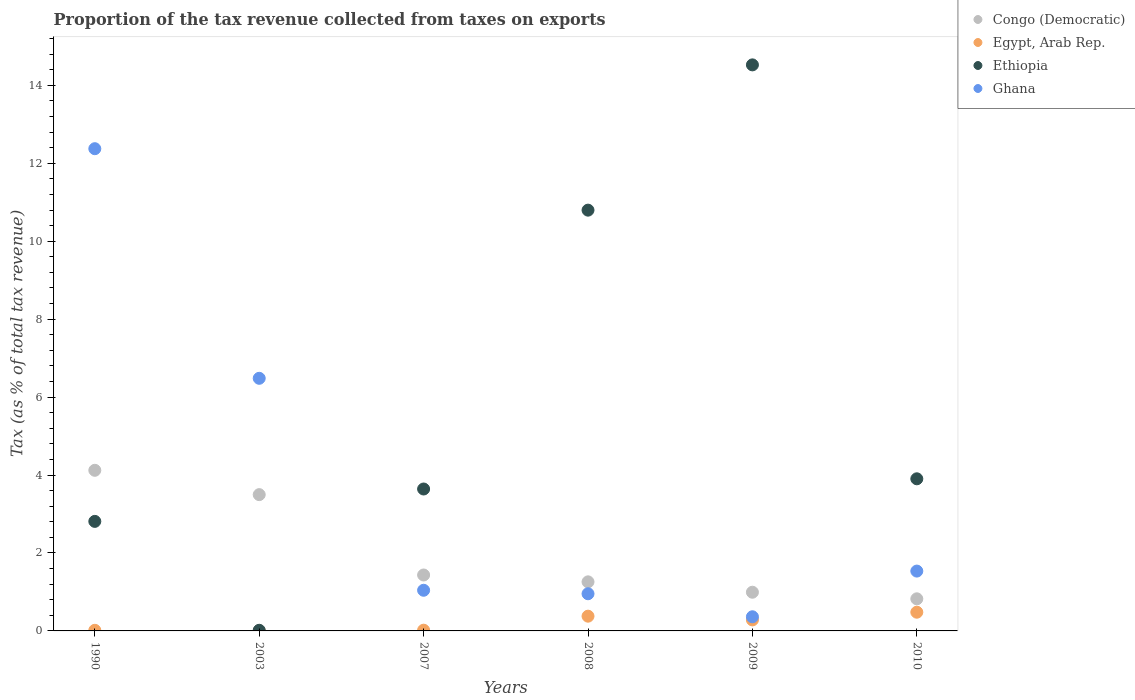How many different coloured dotlines are there?
Provide a succinct answer. 4. What is the proportion of the tax revenue collected in Egypt, Arab Rep. in 2009?
Provide a succinct answer. 0.28. Across all years, what is the maximum proportion of the tax revenue collected in Egypt, Arab Rep.?
Provide a succinct answer. 0.48. Across all years, what is the minimum proportion of the tax revenue collected in Ghana?
Your response must be concise. 0.36. In which year was the proportion of the tax revenue collected in Ethiopia minimum?
Make the answer very short. 2003. What is the total proportion of the tax revenue collected in Ghana in the graph?
Ensure brevity in your answer.  22.75. What is the difference between the proportion of the tax revenue collected in Egypt, Arab Rep. in 2003 and that in 2008?
Offer a very short reply. -0.38. What is the difference between the proportion of the tax revenue collected in Ghana in 2009 and the proportion of the tax revenue collected in Egypt, Arab Rep. in 2010?
Your answer should be compact. -0.12. What is the average proportion of the tax revenue collected in Congo (Democratic) per year?
Provide a succinct answer. 2.02. In the year 2008, what is the difference between the proportion of the tax revenue collected in Congo (Democratic) and proportion of the tax revenue collected in Ethiopia?
Give a very brief answer. -9.54. In how many years, is the proportion of the tax revenue collected in Ethiopia greater than 8.4 %?
Make the answer very short. 2. What is the ratio of the proportion of the tax revenue collected in Congo (Democratic) in 1990 to that in 2010?
Give a very brief answer. 5. Is the proportion of the tax revenue collected in Egypt, Arab Rep. in 2009 less than that in 2010?
Your response must be concise. Yes. Is the difference between the proportion of the tax revenue collected in Congo (Democratic) in 2003 and 2007 greater than the difference between the proportion of the tax revenue collected in Ethiopia in 2003 and 2007?
Keep it short and to the point. Yes. What is the difference between the highest and the second highest proportion of the tax revenue collected in Ethiopia?
Provide a succinct answer. 3.73. What is the difference between the highest and the lowest proportion of the tax revenue collected in Egypt, Arab Rep.?
Your answer should be very brief. 0.48. In how many years, is the proportion of the tax revenue collected in Ethiopia greater than the average proportion of the tax revenue collected in Ethiopia taken over all years?
Ensure brevity in your answer.  2. Is it the case that in every year, the sum of the proportion of the tax revenue collected in Egypt, Arab Rep. and proportion of the tax revenue collected in Ghana  is greater than the sum of proportion of the tax revenue collected in Ethiopia and proportion of the tax revenue collected in Congo (Democratic)?
Offer a terse response. No. Is the proportion of the tax revenue collected in Egypt, Arab Rep. strictly less than the proportion of the tax revenue collected in Ghana over the years?
Provide a short and direct response. Yes. How many dotlines are there?
Offer a terse response. 4. Are the values on the major ticks of Y-axis written in scientific E-notation?
Provide a short and direct response. No. How are the legend labels stacked?
Provide a succinct answer. Vertical. What is the title of the graph?
Ensure brevity in your answer.  Proportion of the tax revenue collected from taxes on exports. What is the label or title of the X-axis?
Give a very brief answer. Years. What is the label or title of the Y-axis?
Provide a succinct answer. Tax (as % of total tax revenue). What is the Tax (as % of total tax revenue) in Congo (Democratic) in 1990?
Make the answer very short. 4.12. What is the Tax (as % of total tax revenue) of Egypt, Arab Rep. in 1990?
Provide a short and direct response. 0.02. What is the Tax (as % of total tax revenue) of Ethiopia in 1990?
Keep it short and to the point. 2.81. What is the Tax (as % of total tax revenue) of Ghana in 1990?
Ensure brevity in your answer.  12.37. What is the Tax (as % of total tax revenue) of Congo (Democratic) in 2003?
Provide a short and direct response. 3.5. What is the Tax (as % of total tax revenue) in Egypt, Arab Rep. in 2003?
Your answer should be very brief. 0. What is the Tax (as % of total tax revenue) of Ethiopia in 2003?
Provide a short and direct response. 0.02. What is the Tax (as % of total tax revenue) of Ghana in 2003?
Offer a very short reply. 6.48. What is the Tax (as % of total tax revenue) of Congo (Democratic) in 2007?
Keep it short and to the point. 1.44. What is the Tax (as % of total tax revenue) in Egypt, Arab Rep. in 2007?
Offer a very short reply. 0.02. What is the Tax (as % of total tax revenue) of Ethiopia in 2007?
Your answer should be very brief. 3.64. What is the Tax (as % of total tax revenue) of Ghana in 2007?
Your response must be concise. 1.04. What is the Tax (as % of total tax revenue) of Congo (Democratic) in 2008?
Keep it short and to the point. 1.26. What is the Tax (as % of total tax revenue) of Egypt, Arab Rep. in 2008?
Offer a terse response. 0.38. What is the Tax (as % of total tax revenue) of Ethiopia in 2008?
Your response must be concise. 10.8. What is the Tax (as % of total tax revenue) of Ghana in 2008?
Give a very brief answer. 0.95. What is the Tax (as % of total tax revenue) in Congo (Democratic) in 2009?
Your answer should be compact. 0.99. What is the Tax (as % of total tax revenue) of Egypt, Arab Rep. in 2009?
Offer a terse response. 0.28. What is the Tax (as % of total tax revenue) in Ethiopia in 2009?
Give a very brief answer. 14.53. What is the Tax (as % of total tax revenue) of Ghana in 2009?
Provide a succinct answer. 0.36. What is the Tax (as % of total tax revenue) of Congo (Democratic) in 2010?
Your answer should be compact. 0.82. What is the Tax (as % of total tax revenue) of Egypt, Arab Rep. in 2010?
Your response must be concise. 0.48. What is the Tax (as % of total tax revenue) in Ethiopia in 2010?
Provide a short and direct response. 3.9. What is the Tax (as % of total tax revenue) in Ghana in 2010?
Ensure brevity in your answer.  1.54. Across all years, what is the maximum Tax (as % of total tax revenue) in Congo (Democratic)?
Offer a very short reply. 4.12. Across all years, what is the maximum Tax (as % of total tax revenue) of Egypt, Arab Rep.?
Offer a very short reply. 0.48. Across all years, what is the maximum Tax (as % of total tax revenue) in Ethiopia?
Your response must be concise. 14.53. Across all years, what is the maximum Tax (as % of total tax revenue) in Ghana?
Make the answer very short. 12.37. Across all years, what is the minimum Tax (as % of total tax revenue) of Congo (Democratic)?
Provide a succinct answer. 0.82. Across all years, what is the minimum Tax (as % of total tax revenue) in Egypt, Arab Rep.?
Your answer should be very brief. 0. Across all years, what is the minimum Tax (as % of total tax revenue) in Ethiopia?
Your answer should be compact. 0.02. Across all years, what is the minimum Tax (as % of total tax revenue) in Ghana?
Offer a very short reply. 0.36. What is the total Tax (as % of total tax revenue) of Congo (Democratic) in the graph?
Offer a terse response. 12.13. What is the total Tax (as % of total tax revenue) in Egypt, Arab Rep. in the graph?
Provide a short and direct response. 1.18. What is the total Tax (as % of total tax revenue) in Ethiopia in the graph?
Keep it short and to the point. 35.7. What is the total Tax (as % of total tax revenue) of Ghana in the graph?
Your answer should be compact. 22.75. What is the difference between the Tax (as % of total tax revenue) of Congo (Democratic) in 1990 and that in 2003?
Provide a succinct answer. 0.62. What is the difference between the Tax (as % of total tax revenue) of Egypt, Arab Rep. in 1990 and that in 2003?
Offer a terse response. 0.01. What is the difference between the Tax (as % of total tax revenue) of Ethiopia in 1990 and that in 2003?
Your answer should be compact. 2.79. What is the difference between the Tax (as % of total tax revenue) of Ghana in 1990 and that in 2003?
Give a very brief answer. 5.89. What is the difference between the Tax (as % of total tax revenue) of Congo (Democratic) in 1990 and that in 2007?
Offer a terse response. 2.69. What is the difference between the Tax (as % of total tax revenue) in Egypt, Arab Rep. in 1990 and that in 2007?
Keep it short and to the point. -0. What is the difference between the Tax (as % of total tax revenue) of Ethiopia in 1990 and that in 2007?
Offer a very short reply. -0.83. What is the difference between the Tax (as % of total tax revenue) in Ghana in 1990 and that in 2007?
Make the answer very short. 11.33. What is the difference between the Tax (as % of total tax revenue) of Congo (Democratic) in 1990 and that in 2008?
Ensure brevity in your answer.  2.86. What is the difference between the Tax (as % of total tax revenue) in Egypt, Arab Rep. in 1990 and that in 2008?
Give a very brief answer. -0.36. What is the difference between the Tax (as % of total tax revenue) in Ethiopia in 1990 and that in 2008?
Make the answer very short. -7.99. What is the difference between the Tax (as % of total tax revenue) of Ghana in 1990 and that in 2008?
Provide a succinct answer. 11.42. What is the difference between the Tax (as % of total tax revenue) in Congo (Democratic) in 1990 and that in 2009?
Offer a very short reply. 3.13. What is the difference between the Tax (as % of total tax revenue) in Egypt, Arab Rep. in 1990 and that in 2009?
Keep it short and to the point. -0.27. What is the difference between the Tax (as % of total tax revenue) in Ethiopia in 1990 and that in 2009?
Keep it short and to the point. -11.71. What is the difference between the Tax (as % of total tax revenue) of Ghana in 1990 and that in 2009?
Ensure brevity in your answer.  12.01. What is the difference between the Tax (as % of total tax revenue) of Congo (Democratic) in 1990 and that in 2010?
Your response must be concise. 3.3. What is the difference between the Tax (as % of total tax revenue) of Egypt, Arab Rep. in 1990 and that in 2010?
Ensure brevity in your answer.  -0.46. What is the difference between the Tax (as % of total tax revenue) in Ethiopia in 1990 and that in 2010?
Provide a short and direct response. -1.09. What is the difference between the Tax (as % of total tax revenue) of Ghana in 1990 and that in 2010?
Offer a terse response. 10.84. What is the difference between the Tax (as % of total tax revenue) in Congo (Democratic) in 2003 and that in 2007?
Make the answer very short. 2.06. What is the difference between the Tax (as % of total tax revenue) of Egypt, Arab Rep. in 2003 and that in 2007?
Your answer should be very brief. -0.02. What is the difference between the Tax (as % of total tax revenue) in Ethiopia in 2003 and that in 2007?
Keep it short and to the point. -3.63. What is the difference between the Tax (as % of total tax revenue) of Ghana in 2003 and that in 2007?
Your response must be concise. 5.44. What is the difference between the Tax (as % of total tax revenue) in Congo (Democratic) in 2003 and that in 2008?
Your answer should be very brief. 2.24. What is the difference between the Tax (as % of total tax revenue) in Egypt, Arab Rep. in 2003 and that in 2008?
Your answer should be compact. -0.38. What is the difference between the Tax (as % of total tax revenue) of Ethiopia in 2003 and that in 2008?
Your answer should be compact. -10.78. What is the difference between the Tax (as % of total tax revenue) in Ghana in 2003 and that in 2008?
Make the answer very short. 5.53. What is the difference between the Tax (as % of total tax revenue) of Congo (Democratic) in 2003 and that in 2009?
Offer a terse response. 2.5. What is the difference between the Tax (as % of total tax revenue) of Egypt, Arab Rep. in 2003 and that in 2009?
Your answer should be very brief. -0.28. What is the difference between the Tax (as % of total tax revenue) of Ethiopia in 2003 and that in 2009?
Give a very brief answer. -14.51. What is the difference between the Tax (as % of total tax revenue) in Ghana in 2003 and that in 2009?
Your response must be concise. 6.12. What is the difference between the Tax (as % of total tax revenue) in Congo (Democratic) in 2003 and that in 2010?
Offer a terse response. 2.67. What is the difference between the Tax (as % of total tax revenue) in Egypt, Arab Rep. in 2003 and that in 2010?
Your response must be concise. -0.48. What is the difference between the Tax (as % of total tax revenue) of Ethiopia in 2003 and that in 2010?
Keep it short and to the point. -3.89. What is the difference between the Tax (as % of total tax revenue) of Ghana in 2003 and that in 2010?
Ensure brevity in your answer.  4.95. What is the difference between the Tax (as % of total tax revenue) in Congo (Democratic) in 2007 and that in 2008?
Make the answer very short. 0.18. What is the difference between the Tax (as % of total tax revenue) in Egypt, Arab Rep. in 2007 and that in 2008?
Provide a short and direct response. -0.36. What is the difference between the Tax (as % of total tax revenue) of Ethiopia in 2007 and that in 2008?
Your response must be concise. -7.16. What is the difference between the Tax (as % of total tax revenue) in Ghana in 2007 and that in 2008?
Ensure brevity in your answer.  0.09. What is the difference between the Tax (as % of total tax revenue) of Congo (Democratic) in 2007 and that in 2009?
Make the answer very short. 0.44. What is the difference between the Tax (as % of total tax revenue) in Egypt, Arab Rep. in 2007 and that in 2009?
Offer a terse response. -0.26. What is the difference between the Tax (as % of total tax revenue) of Ethiopia in 2007 and that in 2009?
Ensure brevity in your answer.  -10.88. What is the difference between the Tax (as % of total tax revenue) in Ghana in 2007 and that in 2009?
Offer a very short reply. 0.68. What is the difference between the Tax (as % of total tax revenue) of Congo (Democratic) in 2007 and that in 2010?
Provide a short and direct response. 0.61. What is the difference between the Tax (as % of total tax revenue) of Egypt, Arab Rep. in 2007 and that in 2010?
Provide a short and direct response. -0.46. What is the difference between the Tax (as % of total tax revenue) in Ethiopia in 2007 and that in 2010?
Your response must be concise. -0.26. What is the difference between the Tax (as % of total tax revenue) of Ghana in 2007 and that in 2010?
Offer a very short reply. -0.49. What is the difference between the Tax (as % of total tax revenue) in Congo (Democratic) in 2008 and that in 2009?
Provide a short and direct response. 0.27. What is the difference between the Tax (as % of total tax revenue) of Egypt, Arab Rep. in 2008 and that in 2009?
Offer a terse response. 0.1. What is the difference between the Tax (as % of total tax revenue) in Ethiopia in 2008 and that in 2009?
Your answer should be very brief. -3.73. What is the difference between the Tax (as % of total tax revenue) in Ghana in 2008 and that in 2009?
Keep it short and to the point. 0.59. What is the difference between the Tax (as % of total tax revenue) of Congo (Democratic) in 2008 and that in 2010?
Your response must be concise. 0.44. What is the difference between the Tax (as % of total tax revenue) of Egypt, Arab Rep. in 2008 and that in 2010?
Provide a short and direct response. -0.1. What is the difference between the Tax (as % of total tax revenue) of Ethiopia in 2008 and that in 2010?
Your answer should be very brief. 6.89. What is the difference between the Tax (as % of total tax revenue) of Ghana in 2008 and that in 2010?
Ensure brevity in your answer.  -0.58. What is the difference between the Tax (as % of total tax revenue) in Congo (Democratic) in 2009 and that in 2010?
Make the answer very short. 0.17. What is the difference between the Tax (as % of total tax revenue) of Egypt, Arab Rep. in 2009 and that in 2010?
Provide a short and direct response. -0.2. What is the difference between the Tax (as % of total tax revenue) in Ethiopia in 2009 and that in 2010?
Offer a terse response. 10.62. What is the difference between the Tax (as % of total tax revenue) in Ghana in 2009 and that in 2010?
Offer a terse response. -1.17. What is the difference between the Tax (as % of total tax revenue) in Congo (Democratic) in 1990 and the Tax (as % of total tax revenue) in Egypt, Arab Rep. in 2003?
Ensure brevity in your answer.  4.12. What is the difference between the Tax (as % of total tax revenue) of Congo (Democratic) in 1990 and the Tax (as % of total tax revenue) of Ethiopia in 2003?
Give a very brief answer. 4.11. What is the difference between the Tax (as % of total tax revenue) of Congo (Democratic) in 1990 and the Tax (as % of total tax revenue) of Ghana in 2003?
Give a very brief answer. -2.36. What is the difference between the Tax (as % of total tax revenue) in Egypt, Arab Rep. in 1990 and the Tax (as % of total tax revenue) in Ethiopia in 2003?
Ensure brevity in your answer.  -0. What is the difference between the Tax (as % of total tax revenue) of Egypt, Arab Rep. in 1990 and the Tax (as % of total tax revenue) of Ghana in 2003?
Ensure brevity in your answer.  -6.47. What is the difference between the Tax (as % of total tax revenue) in Ethiopia in 1990 and the Tax (as % of total tax revenue) in Ghana in 2003?
Ensure brevity in your answer.  -3.67. What is the difference between the Tax (as % of total tax revenue) of Congo (Democratic) in 1990 and the Tax (as % of total tax revenue) of Egypt, Arab Rep. in 2007?
Give a very brief answer. 4.1. What is the difference between the Tax (as % of total tax revenue) in Congo (Democratic) in 1990 and the Tax (as % of total tax revenue) in Ethiopia in 2007?
Offer a terse response. 0.48. What is the difference between the Tax (as % of total tax revenue) in Congo (Democratic) in 1990 and the Tax (as % of total tax revenue) in Ghana in 2007?
Your answer should be very brief. 3.08. What is the difference between the Tax (as % of total tax revenue) of Egypt, Arab Rep. in 1990 and the Tax (as % of total tax revenue) of Ethiopia in 2007?
Your answer should be compact. -3.63. What is the difference between the Tax (as % of total tax revenue) in Egypt, Arab Rep. in 1990 and the Tax (as % of total tax revenue) in Ghana in 2007?
Provide a succinct answer. -1.03. What is the difference between the Tax (as % of total tax revenue) in Ethiopia in 1990 and the Tax (as % of total tax revenue) in Ghana in 2007?
Offer a terse response. 1.77. What is the difference between the Tax (as % of total tax revenue) in Congo (Democratic) in 1990 and the Tax (as % of total tax revenue) in Egypt, Arab Rep. in 2008?
Give a very brief answer. 3.74. What is the difference between the Tax (as % of total tax revenue) of Congo (Democratic) in 1990 and the Tax (as % of total tax revenue) of Ethiopia in 2008?
Provide a succinct answer. -6.68. What is the difference between the Tax (as % of total tax revenue) of Congo (Democratic) in 1990 and the Tax (as % of total tax revenue) of Ghana in 2008?
Give a very brief answer. 3.17. What is the difference between the Tax (as % of total tax revenue) in Egypt, Arab Rep. in 1990 and the Tax (as % of total tax revenue) in Ethiopia in 2008?
Make the answer very short. -10.78. What is the difference between the Tax (as % of total tax revenue) in Egypt, Arab Rep. in 1990 and the Tax (as % of total tax revenue) in Ghana in 2008?
Provide a succinct answer. -0.94. What is the difference between the Tax (as % of total tax revenue) of Ethiopia in 1990 and the Tax (as % of total tax revenue) of Ghana in 2008?
Your answer should be compact. 1.86. What is the difference between the Tax (as % of total tax revenue) in Congo (Democratic) in 1990 and the Tax (as % of total tax revenue) in Egypt, Arab Rep. in 2009?
Provide a short and direct response. 3.84. What is the difference between the Tax (as % of total tax revenue) in Congo (Democratic) in 1990 and the Tax (as % of total tax revenue) in Ethiopia in 2009?
Your answer should be compact. -10.4. What is the difference between the Tax (as % of total tax revenue) in Congo (Democratic) in 1990 and the Tax (as % of total tax revenue) in Ghana in 2009?
Provide a short and direct response. 3.76. What is the difference between the Tax (as % of total tax revenue) in Egypt, Arab Rep. in 1990 and the Tax (as % of total tax revenue) in Ethiopia in 2009?
Provide a succinct answer. -14.51. What is the difference between the Tax (as % of total tax revenue) of Egypt, Arab Rep. in 1990 and the Tax (as % of total tax revenue) of Ghana in 2009?
Your response must be concise. -0.35. What is the difference between the Tax (as % of total tax revenue) of Ethiopia in 1990 and the Tax (as % of total tax revenue) of Ghana in 2009?
Your answer should be very brief. 2.45. What is the difference between the Tax (as % of total tax revenue) in Congo (Democratic) in 1990 and the Tax (as % of total tax revenue) in Egypt, Arab Rep. in 2010?
Your response must be concise. 3.64. What is the difference between the Tax (as % of total tax revenue) of Congo (Democratic) in 1990 and the Tax (as % of total tax revenue) of Ethiopia in 2010?
Provide a short and direct response. 0.22. What is the difference between the Tax (as % of total tax revenue) of Congo (Democratic) in 1990 and the Tax (as % of total tax revenue) of Ghana in 2010?
Provide a short and direct response. 2.59. What is the difference between the Tax (as % of total tax revenue) of Egypt, Arab Rep. in 1990 and the Tax (as % of total tax revenue) of Ethiopia in 2010?
Offer a very short reply. -3.89. What is the difference between the Tax (as % of total tax revenue) in Egypt, Arab Rep. in 1990 and the Tax (as % of total tax revenue) in Ghana in 2010?
Your response must be concise. -1.52. What is the difference between the Tax (as % of total tax revenue) in Ethiopia in 1990 and the Tax (as % of total tax revenue) in Ghana in 2010?
Provide a short and direct response. 1.28. What is the difference between the Tax (as % of total tax revenue) in Congo (Democratic) in 2003 and the Tax (as % of total tax revenue) in Egypt, Arab Rep. in 2007?
Give a very brief answer. 3.48. What is the difference between the Tax (as % of total tax revenue) in Congo (Democratic) in 2003 and the Tax (as % of total tax revenue) in Ethiopia in 2007?
Your answer should be very brief. -0.14. What is the difference between the Tax (as % of total tax revenue) in Congo (Democratic) in 2003 and the Tax (as % of total tax revenue) in Ghana in 2007?
Offer a terse response. 2.45. What is the difference between the Tax (as % of total tax revenue) of Egypt, Arab Rep. in 2003 and the Tax (as % of total tax revenue) of Ethiopia in 2007?
Provide a short and direct response. -3.64. What is the difference between the Tax (as % of total tax revenue) in Egypt, Arab Rep. in 2003 and the Tax (as % of total tax revenue) in Ghana in 2007?
Ensure brevity in your answer.  -1.04. What is the difference between the Tax (as % of total tax revenue) of Ethiopia in 2003 and the Tax (as % of total tax revenue) of Ghana in 2007?
Provide a succinct answer. -1.03. What is the difference between the Tax (as % of total tax revenue) of Congo (Democratic) in 2003 and the Tax (as % of total tax revenue) of Egypt, Arab Rep. in 2008?
Keep it short and to the point. 3.12. What is the difference between the Tax (as % of total tax revenue) in Congo (Democratic) in 2003 and the Tax (as % of total tax revenue) in Ethiopia in 2008?
Keep it short and to the point. -7.3. What is the difference between the Tax (as % of total tax revenue) of Congo (Democratic) in 2003 and the Tax (as % of total tax revenue) of Ghana in 2008?
Ensure brevity in your answer.  2.54. What is the difference between the Tax (as % of total tax revenue) in Egypt, Arab Rep. in 2003 and the Tax (as % of total tax revenue) in Ethiopia in 2008?
Provide a short and direct response. -10.8. What is the difference between the Tax (as % of total tax revenue) of Egypt, Arab Rep. in 2003 and the Tax (as % of total tax revenue) of Ghana in 2008?
Provide a short and direct response. -0.95. What is the difference between the Tax (as % of total tax revenue) in Ethiopia in 2003 and the Tax (as % of total tax revenue) in Ghana in 2008?
Give a very brief answer. -0.94. What is the difference between the Tax (as % of total tax revenue) of Congo (Democratic) in 2003 and the Tax (as % of total tax revenue) of Egypt, Arab Rep. in 2009?
Your response must be concise. 3.21. What is the difference between the Tax (as % of total tax revenue) of Congo (Democratic) in 2003 and the Tax (as % of total tax revenue) of Ethiopia in 2009?
Your response must be concise. -11.03. What is the difference between the Tax (as % of total tax revenue) of Congo (Democratic) in 2003 and the Tax (as % of total tax revenue) of Ghana in 2009?
Make the answer very short. 3.13. What is the difference between the Tax (as % of total tax revenue) in Egypt, Arab Rep. in 2003 and the Tax (as % of total tax revenue) in Ethiopia in 2009?
Offer a terse response. -14.52. What is the difference between the Tax (as % of total tax revenue) in Egypt, Arab Rep. in 2003 and the Tax (as % of total tax revenue) in Ghana in 2009?
Your answer should be compact. -0.36. What is the difference between the Tax (as % of total tax revenue) in Ethiopia in 2003 and the Tax (as % of total tax revenue) in Ghana in 2009?
Your answer should be very brief. -0.35. What is the difference between the Tax (as % of total tax revenue) in Congo (Democratic) in 2003 and the Tax (as % of total tax revenue) in Egypt, Arab Rep. in 2010?
Make the answer very short. 3.02. What is the difference between the Tax (as % of total tax revenue) of Congo (Democratic) in 2003 and the Tax (as % of total tax revenue) of Ethiopia in 2010?
Your response must be concise. -0.41. What is the difference between the Tax (as % of total tax revenue) of Congo (Democratic) in 2003 and the Tax (as % of total tax revenue) of Ghana in 2010?
Your answer should be compact. 1.96. What is the difference between the Tax (as % of total tax revenue) in Egypt, Arab Rep. in 2003 and the Tax (as % of total tax revenue) in Ethiopia in 2010?
Make the answer very short. -3.9. What is the difference between the Tax (as % of total tax revenue) of Egypt, Arab Rep. in 2003 and the Tax (as % of total tax revenue) of Ghana in 2010?
Ensure brevity in your answer.  -1.53. What is the difference between the Tax (as % of total tax revenue) in Ethiopia in 2003 and the Tax (as % of total tax revenue) in Ghana in 2010?
Provide a short and direct response. -1.52. What is the difference between the Tax (as % of total tax revenue) of Congo (Democratic) in 2007 and the Tax (as % of total tax revenue) of Egypt, Arab Rep. in 2008?
Offer a very short reply. 1.06. What is the difference between the Tax (as % of total tax revenue) of Congo (Democratic) in 2007 and the Tax (as % of total tax revenue) of Ethiopia in 2008?
Offer a very short reply. -9.36. What is the difference between the Tax (as % of total tax revenue) of Congo (Democratic) in 2007 and the Tax (as % of total tax revenue) of Ghana in 2008?
Offer a terse response. 0.48. What is the difference between the Tax (as % of total tax revenue) of Egypt, Arab Rep. in 2007 and the Tax (as % of total tax revenue) of Ethiopia in 2008?
Give a very brief answer. -10.78. What is the difference between the Tax (as % of total tax revenue) in Egypt, Arab Rep. in 2007 and the Tax (as % of total tax revenue) in Ghana in 2008?
Provide a succinct answer. -0.93. What is the difference between the Tax (as % of total tax revenue) in Ethiopia in 2007 and the Tax (as % of total tax revenue) in Ghana in 2008?
Make the answer very short. 2.69. What is the difference between the Tax (as % of total tax revenue) of Congo (Democratic) in 2007 and the Tax (as % of total tax revenue) of Egypt, Arab Rep. in 2009?
Your answer should be very brief. 1.15. What is the difference between the Tax (as % of total tax revenue) of Congo (Democratic) in 2007 and the Tax (as % of total tax revenue) of Ethiopia in 2009?
Make the answer very short. -13.09. What is the difference between the Tax (as % of total tax revenue) of Congo (Democratic) in 2007 and the Tax (as % of total tax revenue) of Ghana in 2009?
Your response must be concise. 1.07. What is the difference between the Tax (as % of total tax revenue) of Egypt, Arab Rep. in 2007 and the Tax (as % of total tax revenue) of Ethiopia in 2009?
Your answer should be very brief. -14.51. What is the difference between the Tax (as % of total tax revenue) of Egypt, Arab Rep. in 2007 and the Tax (as % of total tax revenue) of Ghana in 2009?
Give a very brief answer. -0.34. What is the difference between the Tax (as % of total tax revenue) of Ethiopia in 2007 and the Tax (as % of total tax revenue) of Ghana in 2009?
Your response must be concise. 3.28. What is the difference between the Tax (as % of total tax revenue) of Congo (Democratic) in 2007 and the Tax (as % of total tax revenue) of Egypt, Arab Rep. in 2010?
Provide a succinct answer. 0.95. What is the difference between the Tax (as % of total tax revenue) in Congo (Democratic) in 2007 and the Tax (as % of total tax revenue) in Ethiopia in 2010?
Offer a terse response. -2.47. What is the difference between the Tax (as % of total tax revenue) in Congo (Democratic) in 2007 and the Tax (as % of total tax revenue) in Ghana in 2010?
Give a very brief answer. -0.1. What is the difference between the Tax (as % of total tax revenue) in Egypt, Arab Rep. in 2007 and the Tax (as % of total tax revenue) in Ethiopia in 2010?
Offer a very short reply. -3.88. What is the difference between the Tax (as % of total tax revenue) of Egypt, Arab Rep. in 2007 and the Tax (as % of total tax revenue) of Ghana in 2010?
Your answer should be very brief. -1.52. What is the difference between the Tax (as % of total tax revenue) in Ethiopia in 2007 and the Tax (as % of total tax revenue) in Ghana in 2010?
Your answer should be very brief. 2.11. What is the difference between the Tax (as % of total tax revenue) in Congo (Democratic) in 2008 and the Tax (as % of total tax revenue) in Egypt, Arab Rep. in 2009?
Your response must be concise. 0.98. What is the difference between the Tax (as % of total tax revenue) of Congo (Democratic) in 2008 and the Tax (as % of total tax revenue) of Ethiopia in 2009?
Offer a terse response. -13.27. What is the difference between the Tax (as % of total tax revenue) in Congo (Democratic) in 2008 and the Tax (as % of total tax revenue) in Ghana in 2009?
Your response must be concise. 0.9. What is the difference between the Tax (as % of total tax revenue) in Egypt, Arab Rep. in 2008 and the Tax (as % of total tax revenue) in Ethiopia in 2009?
Make the answer very short. -14.15. What is the difference between the Tax (as % of total tax revenue) of Egypt, Arab Rep. in 2008 and the Tax (as % of total tax revenue) of Ghana in 2009?
Give a very brief answer. 0.02. What is the difference between the Tax (as % of total tax revenue) of Ethiopia in 2008 and the Tax (as % of total tax revenue) of Ghana in 2009?
Your answer should be very brief. 10.43. What is the difference between the Tax (as % of total tax revenue) in Congo (Democratic) in 2008 and the Tax (as % of total tax revenue) in Egypt, Arab Rep. in 2010?
Your answer should be compact. 0.78. What is the difference between the Tax (as % of total tax revenue) of Congo (Democratic) in 2008 and the Tax (as % of total tax revenue) of Ethiopia in 2010?
Your answer should be very brief. -2.64. What is the difference between the Tax (as % of total tax revenue) in Congo (Democratic) in 2008 and the Tax (as % of total tax revenue) in Ghana in 2010?
Your answer should be very brief. -0.28. What is the difference between the Tax (as % of total tax revenue) in Egypt, Arab Rep. in 2008 and the Tax (as % of total tax revenue) in Ethiopia in 2010?
Make the answer very short. -3.53. What is the difference between the Tax (as % of total tax revenue) in Egypt, Arab Rep. in 2008 and the Tax (as % of total tax revenue) in Ghana in 2010?
Your response must be concise. -1.16. What is the difference between the Tax (as % of total tax revenue) of Ethiopia in 2008 and the Tax (as % of total tax revenue) of Ghana in 2010?
Your response must be concise. 9.26. What is the difference between the Tax (as % of total tax revenue) in Congo (Democratic) in 2009 and the Tax (as % of total tax revenue) in Egypt, Arab Rep. in 2010?
Provide a succinct answer. 0.51. What is the difference between the Tax (as % of total tax revenue) in Congo (Democratic) in 2009 and the Tax (as % of total tax revenue) in Ethiopia in 2010?
Offer a very short reply. -2.91. What is the difference between the Tax (as % of total tax revenue) of Congo (Democratic) in 2009 and the Tax (as % of total tax revenue) of Ghana in 2010?
Your answer should be very brief. -0.54. What is the difference between the Tax (as % of total tax revenue) of Egypt, Arab Rep. in 2009 and the Tax (as % of total tax revenue) of Ethiopia in 2010?
Provide a succinct answer. -3.62. What is the difference between the Tax (as % of total tax revenue) in Egypt, Arab Rep. in 2009 and the Tax (as % of total tax revenue) in Ghana in 2010?
Keep it short and to the point. -1.25. What is the difference between the Tax (as % of total tax revenue) of Ethiopia in 2009 and the Tax (as % of total tax revenue) of Ghana in 2010?
Your answer should be very brief. 12.99. What is the average Tax (as % of total tax revenue) in Congo (Democratic) per year?
Provide a short and direct response. 2.02. What is the average Tax (as % of total tax revenue) of Egypt, Arab Rep. per year?
Offer a terse response. 0.2. What is the average Tax (as % of total tax revenue) of Ethiopia per year?
Your answer should be compact. 5.95. What is the average Tax (as % of total tax revenue) in Ghana per year?
Give a very brief answer. 3.79. In the year 1990, what is the difference between the Tax (as % of total tax revenue) of Congo (Democratic) and Tax (as % of total tax revenue) of Egypt, Arab Rep.?
Give a very brief answer. 4.11. In the year 1990, what is the difference between the Tax (as % of total tax revenue) of Congo (Democratic) and Tax (as % of total tax revenue) of Ethiopia?
Provide a short and direct response. 1.31. In the year 1990, what is the difference between the Tax (as % of total tax revenue) of Congo (Democratic) and Tax (as % of total tax revenue) of Ghana?
Give a very brief answer. -8.25. In the year 1990, what is the difference between the Tax (as % of total tax revenue) in Egypt, Arab Rep. and Tax (as % of total tax revenue) in Ethiopia?
Your response must be concise. -2.79. In the year 1990, what is the difference between the Tax (as % of total tax revenue) of Egypt, Arab Rep. and Tax (as % of total tax revenue) of Ghana?
Provide a succinct answer. -12.36. In the year 1990, what is the difference between the Tax (as % of total tax revenue) in Ethiopia and Tax (as % of total tax revenue) in Ghana?
Ensure brevity in your answer.  -9.56. In the year 2003, what is the difference between the Tax (as % of total tax revenue) of Congo (Democratic) and Tax (as % of total tax revenue) of Egypt, Arab Rep.?
Provide a succinct answer. 3.5. In the year 2003, what is the difference between the Tax (as % of total tax revenue) of Congo (Democratic) and Tax (as % of total tax revenue) of Ethiopia?
Ensure brevity in your answer.  3.48. In the year 2003, what is the difference between the Tax (as % of total tax revenue) of Congo (Democratic) and Tax (as % of total tax revenue) of Ghana?
Make the answer very short. -2.99. In the year 2003, what is the difference between the Tax (as % of total tax revenue) of Egypt, Arab Rep. and Tax (as % of total tax revenue) of Ethiopia?
Your response must be concise. -0.01. In the year 2003, what is the difference between the Tax (as % of total tax revenue) of Egypt, Arab Rep. and Tax (as % of total tax revenue) of Ghana?
Provide a succinct answer. -6.48. In the year 2003, what is the difference between the Tax (as % of total tax revenue) in Ethiopia and Tax (as % of total tax revenue) in Ghana?
Offer a terse response. -6.47. In the year 2007, what is the difference between the Tax (as % of total tax revenue) of Congo (Democratic) and Tax (as % of total tax revenue) of Egypt, Arab Rep.?
Your answer should be very brief. 1.42. In the year 2007, what is the difference between the Tax (as % of total tax revenue) in Congo (Democratic) and Tax (as % of total tax revenue) in Ethiopia?
Your answer should be very brief. -2.21. In the year 2007, what is the difference between the Tax (as % of total tax revenue) in Congo (Democratic) and Tax (as % of total tax revenue) in Ghana?
Offer a very short reply. 0.39. In the year 2007, what is the difference between the Tax (as % of total tax revenue) in Egypt, Arab Rep. and Tax (as % of total tax revenue) in Ethiopia?
Keep it short and to the point. -3.62. In the year 2007, what is the difference between the Tax (as % of total tax revenue) of Egypt, Arab Rep. and Tax (as % of total tax revenue) of Ghana?
Offer a terse response. -1.02. In the year 2007, what is the difference between the Tax (as % of total tax revenue) in Ethiopia and Tax (as % of total tax revenue) in Ghana?
Make the answer very short. 2.6. In the year 2008, what is the difference between the Tax (as % of total tax revenue) of Congo (Democratic) and Tax (as % of total tax revenue) of Egypt, Arab Rep.?
Your answer should be compact. 0.88. In the year 2008, what is the difference between the Tax (as % of total tax revenue) of Congo (Democratic) and Tax (as % of total tax revenue) of Ethiopia?
Give a very brief answer. -9.54. In the year 2008, what is the difference between the Tax (as % of total tax revenue) in Congo (Democratic) and Tax (as % of total tax revenue) in Ghana?
Offer a terse response. 0.31. In the year 2008, what is the difference between the Tax (as % of total tax revenue) of Egypt, Arab Rep. and Tax (as % of total tax revenue) of Ethiopia?
Offer a very short reply. -10.42. In the year 2008, what is the difference between the Tax (as % of total tax revenue) in Egypt, Arab Rep. and Tax (as % of total tax revenue) in Ghana?
Your answer should be compact. -0.58. In the year 2008, what is the difference between the Tax (as % of total tax revenue) of Ethiopia and Tax (as % of total tax revenue) of Ghana?
Ensure brevity in your answer.  9.84. In the year 2009, what is the difference between the Tax (as % of total tax revenue) in Congo (Democratic) and Tax (as % of total tax revenue) in Egypt, Arab Rep.?
Your response must be concise. 0.71. In the year 2009, what is the difference between the Tax (as % of total tax revenue) of Congo (Democratic) and Tax (as % of total tax revenue) of Ethiopia?
Offer a very short reply. -13.53. In the year 2009, what is the difference between the Tax (as % of total tax revenue) in Congo (Democratic) and Tax (as % of total tax revenue) in Ghana?
Make the answer very short. 0.63. In the year 2009, what is the difference between the Tax (as % of total tax revenue) of Egypt, Arab Rep. and Tax (as % of total tax revenue) of Ethiopia?
Your response must be concise. -14.24. In the year 2009, what is the difference between the Tax (as % of total tax revenue) in Egypt, Arab Rep. and Tax (as % of total tax revenue) in Ghana?
Provide a short and direct response. -0.08. In the year 2009, what is the difference between the Tax (as % of total tax revenue) in Ethiopia and Tax (as % of total tax revenue) in Ghana?
Give a very brief answer. 14.16. In the year 2010, what is the difference between the Tax (as % of total tax revenue) in Congo (Democratic) and Tax (as % of total tax revenue) in Egypt, Arab Rep.?
Ensure brevity in your answer.  0.34. In the year 2010, what is the difference between the Tax (as % of total tax revenue) of Congo (Democratic) and Tax (as % of total tax revenue) of Ethiopia?
Keep it short and to the point. -3.08. In the year 2010, what is the difference between the Tax (as % of total tax revenue) of Congo (Democratic) and Tax (as % of total tax revenue) of Ghana?
Provide a short and direct response. -0.71. In the year 2010, what is the difference between the Tax (as % of total tax revenue) of Egypt, Arab Rep. and Tax (as % of total tax revenue) of Ethiopia?
Give a very brief answer. -3.42. In the year 2010, what is the difference between the Tax (as % of total tax revenue) in Egypt, Arab Rep. and Tax (as % of total tax revenue) in Ghana?
Give a very brief answer. -1.06. In the year 2010, what is the difference between the Tax (as % of total tax revenue) in Ethiopia and Tax (as % of total tax revenue) in Ghana?
Your response must be concise. 2.37. What is the ratio of the Tax (as % of total tax revenue) in Congo (Democratic) in 1990 to that in 2003?
Your answer should be very brief. 1.18. What is the ratio of the Tax (as % of total tax revenue) in Egypt, Arab Rep. in 1990 to that in 2003?
Your response must be concise. 8.79. What is the ratio of the Tax (as % of total tax revenue) of Ethiopia in 1990 to that in 2003?
Your response must be concise. 172.38. What is the ratio of the Tax (as % of total tax revenue) in Ghana in 1990 to that in 2003?
Make the answer very short. 1.91. What is the ratio of the Tax (as % of total tax revenue) of Congo (Democratic) in 1990 to that in 2007?
Give a very brief answer. 2.87. What is the ratio of the Tax (as % of total tax revenue) in Egypt, Arab Rep. in 1990 to that in 2007?
Ensure brevity in your answer.  0.83. What is the ratio of the Tax (as % of total tax revenue) in Ethiopia in 1990 to that in 2007?
Keep it short and to the point. 0.77. What is the ratio of the Tax (as % of total tax revenue) of Ghana in 1990 to that in 2007?
Provide a short and direct response. 11.86. What is the ratio of the Tax (as % of total tax revenue) of Congo (Democratic) in 1990 to that in 2008?
Ensure brevity in your answer.  3.27. What is the ratio of the Tax (as % of total tax revenue) in Egypt, Arab Rep. in 1990 to that in 2008?
Give a very brief answer. 0.04. What is the ratio of the Tax (as % of total tax revenue) in Ethiopia in 1990 to that in 2008?
Provide a succinct answer. 0.26. What is the ratio of the Tax (as % of total tax revenue) of Ghana in 1990 to that in 2008?
Ensure brevity in your answer.  12.97. What is the ratio of the Tax (as % of total tax revenue) of Congo (Democratic) in 1990 to that in 2009?
Offer a terse response. 4.15. What is the ratio of the Tax (as % of total tax revenue) in Egypt, Arab Rep. in 1990 to that in 2009?
Offer a very short reply. 0.06. What is the ratio of the Tax (as % of total tax revenue) of Ethiopia in 1990 to that in 2009?
Provide a short and direct response. 0.19. What is the ratio of the Tax (as % of total tax revenue) in Ghana in 1990 to that in 2009?
Your answer should be compact. 34.08. What is the ratio of the Tax (as % of total tax revenue) in Congo (Democratic) in 1990 to that in 2010?
Your answer should be very brief. 5. What is the ratio of the Tax (as % of total tax revenue) of Egypt, Arab Rep. in 1990 to that in 2010?
Your response must be concise. 0.03. What is the ratio of the Tax (as % of total tax revenue) in Ethiopia in 1990 to that in 2010?
Offer a terse response. 0.72. What is the ratio of the Tax (as % of total tax revenue) of Ghana in 1990 to that in 2010?
Provide a succinct answer. 8.06. What is the ratio of the Tax (as % of total tax revenue) of Congo (Democratic) in 2003 to that in 2007?
Offer a terse response. 2.44. What is the ratio of the Tax (as % of total tax revenue) in Egypt, Arab Rep. in 2003 to that in 2007?
Provide a short and direct response. 0.1. What is the ratio of the Tax (as % of total tax revenue) of Ethiopia in 2003 to that in 2007?
Provide a succinct answer. 0. What is the ratio of the Tax (as % of total tax revenue) of Ghana in 2003 to that in 2007?
Offer a terse response. 6.21. What is the ratio of the Tax (as % of total tax revenue) in Congo (Democratic) in 2003 to that in 2008?
Ensure brevity in your answer.  2.78. What is the ratio of the Tax (as % of total tax revenue) in Egypt, Arab Rep. in 2003 to that in 2008?
Make the answer very short. 0. What is the ratio of the Tax (as % of total tax revenue) of Ethiopia in 2003 to that in 2008?
Give a very brief answer. 0. What is the ratio of the Tax (as % of total tax revenue) in Ghana in 2003 to that in 2008?
Provide a short and direct response. 6.8. What is the ratio of the Tax (as % of total tax revenue) in Congo (Democratic) in 2003 to that in 2009?
Your response must be concise. 3.52. What is the ratio of the Tax (as % of total tax revenue) in Egypt, Arab Rep. in 2003 to that in 2009?
Offer a terse response. 0.01. What is the ratio of the Tax (as % of total tax revenue) of Ethiopia in 2003 to that in 2009?
Offer a terse response. 0. What is the ratio of the Tax (as % of total tax revenue) of Ghana in 2003 to that in 2009?
Offer a very short reply. 17.85. What is the ratio of the Tax (as % of total tax revenue) in Congo (Democratic) in 2003 to that in 2010?
Keep it short and to the point. 4.25. What is the ratio of the Tax (as % of total tax revenue) of Egypt, Arab Rep. in 2003 to that in 2010?
Your response must be concise. 0. What is the ratio of the Tax (as % of total tax revenue) of Ethiopia in 2003 to that in 2010?
Offer a very short reply. 0. What is the ratio of the Tax (as % of total tax revenue) in Ghana in 2003 to that in 2010?
Your response must be concise. 4.22. What is the ratio of the Tax (as % of total tax revenue) of Congo (Democratic) in 2007 to that in 2008?
Ensure brevity in your answer.  1.14. What is the ratio of the Tax (as % of total tax revenue) of Egypt, Arab Rep. in 2007 to that in 2008?
Offer a very short reply. 0.05. What is the ratio of the Tax (as % of total tax revenue) in Ethiopia in 2007 to that in 2008?
Your answer should be very brief. 0.34. What is the ratio of the Tax (as % of total tax revenue) of Ghana in 2007 to that in 2008?
Provide a succinct answer. 1.09. What is the ratio of the Tax (as % of total tax revenue) of Congo (Democratic) in 2007 to that in 2009?
Provide a succinct answer. 1.45. What is the ratio of the Tax (as % of total tax revenue) in Egypt, Arab Rep. in 2007 to that in 2009?
Give a very brief answer. 0.07. What is the ratio of the Tax (as % of total tax revenue) of Ethiopia in 2007 to that in 2009?
Offer a very short reply. 0.25. What is the ratio of the Tax (as % of total tax revenue) in Ghana in 2007 to that in 2009?
Your answer should be very brief. 2.87. What is the ratio of the Tax (as % of total tax revenue) in Congo (Democratic) in 2007 to that in 2010?
Your answer should be very brief. 1.74. What is the ratio of the Tax (as % of total tax revenue) in Egypt, Arab Rep. in 2007 to that in 2010?
Provide a short and direct response. 0.04. What is the ratio of the Tax (as % of total tax revenue) in Ethiopia in 2007 to that in 2010?
Ensure brevity in your answer.  0.93. What is the ratio of the Tax (as % of total tax revenue) in Ghana in 2007 to that in 2010?
Your answer should be compact. 0.68. What is the ratio of the Tax (as % of total tax revenue) in Congo (Democratic) in 2008 to that in 2009?
Provide a short and direct response. 1.27. What is the ratio of the Tax (as % of total tax revenue) in Egypt, Arab Rep. in 2008 to that in 2009?
Provide a short and direct response. 1.34. What is the ratio of the Tax (as % of total tax revenue) of Ethiopia in 2008 to that in 2009?
Offer a very short reply. 0.74. What is the ratio of the Tax (as % of total tax revenue) of Ghana in 2008 to that in 2009?
Your answer should be very brief. 2.63. What is the ratio of the Tax (as % of total tax revenue) of Congo (Democratic) in 2008 to that in 2010?
Ensure brevity in your answer.  1.53. What is the ratio of the Tax (as % of total tax revenue) of Egypt, Arab Rep. in 2008 to that in 2010?
Ensure brevity in your answer.  0.79. What is the ratio of the Tax (as % of total tax revenue) in Ethiopia in 2008 to that in 2010?
Provide a short and direct response. 2.77. What is the ratio of the Tax (as % of total tax revenue) in Ghana in 2008 to that in 2010?
Provide a short and direct response. 0.62. What is the ratio of the Tax (as % of total tax revenue) in Congo (Democratic) in 2009 to that in 2010?
Ensure brevity in your answer.  1.21. What is the ratio of the Tax (as % of total tax revenue) in Egypt, Arab Rep. in 2009 to that in 2010?
Ensure brevity in your answer.  0.59. What is the ratio of the Tax (as % of total tax revenue) in Ethiopia in 2009 to that in 2010?
Provide a succinct answer. 3.72. What is the ratio of the Tax (as % of total tax revenue) in Ghana in 2009 to that in 2010?
Keep it short and to the point. 0.24. What is the difference between the highest and the second highest Tax (as % of total tax revenue) of Congo (Democratic)?
Offer a very short reply. 0.62. What is the difference between the highest and the second highest Tax (as % of total tax revenue) of Egypt, Arab Rep.?
Ensure brevity in your answer.  0.1. What is the difference between the highest and the second highest Tax (as % of total tax revenue) of Ethiopia?
Keep it short and to the point. 3.73. What is the difference between the highest and the second highest Tax (as % of total tax revenue) of Ghana?
Provide a short and direct response. 5.89. What is the difference between the highest and the lowest Tax (as % of total tax revenue) in Congo (Democratic)?
Your answer should be very brief. 3.3. What is the difference between the highest and the lowest Tax (as % of total tax revenue) in Egypt, Arab Rep.?
Your response must be concise. 0.48. What is the difference between the highest and the lowest Tax (as % of total tax revenue) of Ethiopia?
Provide a succinct answer. 14.51. What is the difference between the highest and the lowest Tax (as % of total tax revenue) in Ghana?
Make the answer very short. 12.01. 